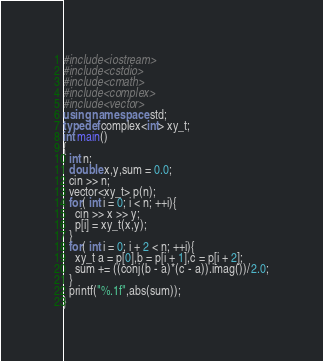<code> <loc_0><loc_0><loc_500><loc_500><_C++_>#include<iostream>
#include<cstdio>
#include<cmath>
#include<complex>
#include<vector>
using namespace std;
typedef complex<int> xy_t;
int main()
{
  int n;
  double x,y,sum = 0.0;
  cin >> n;
  vector<xy_t> p(n);
  for( int i = 0; i < n; ++i){
    cin >> x >> y;
    p[i] = xy_t(x,y);
  }
  for( int i = 0; i + 2 < n; ++i){
    xy_t a = p[0],b = p[i + 1],c = p[i + 2];
    sum += ((conj(b - a)*(c - a)).imag())/2.0;
  }
  printf("%.1f",abs(sum));
}</code> 